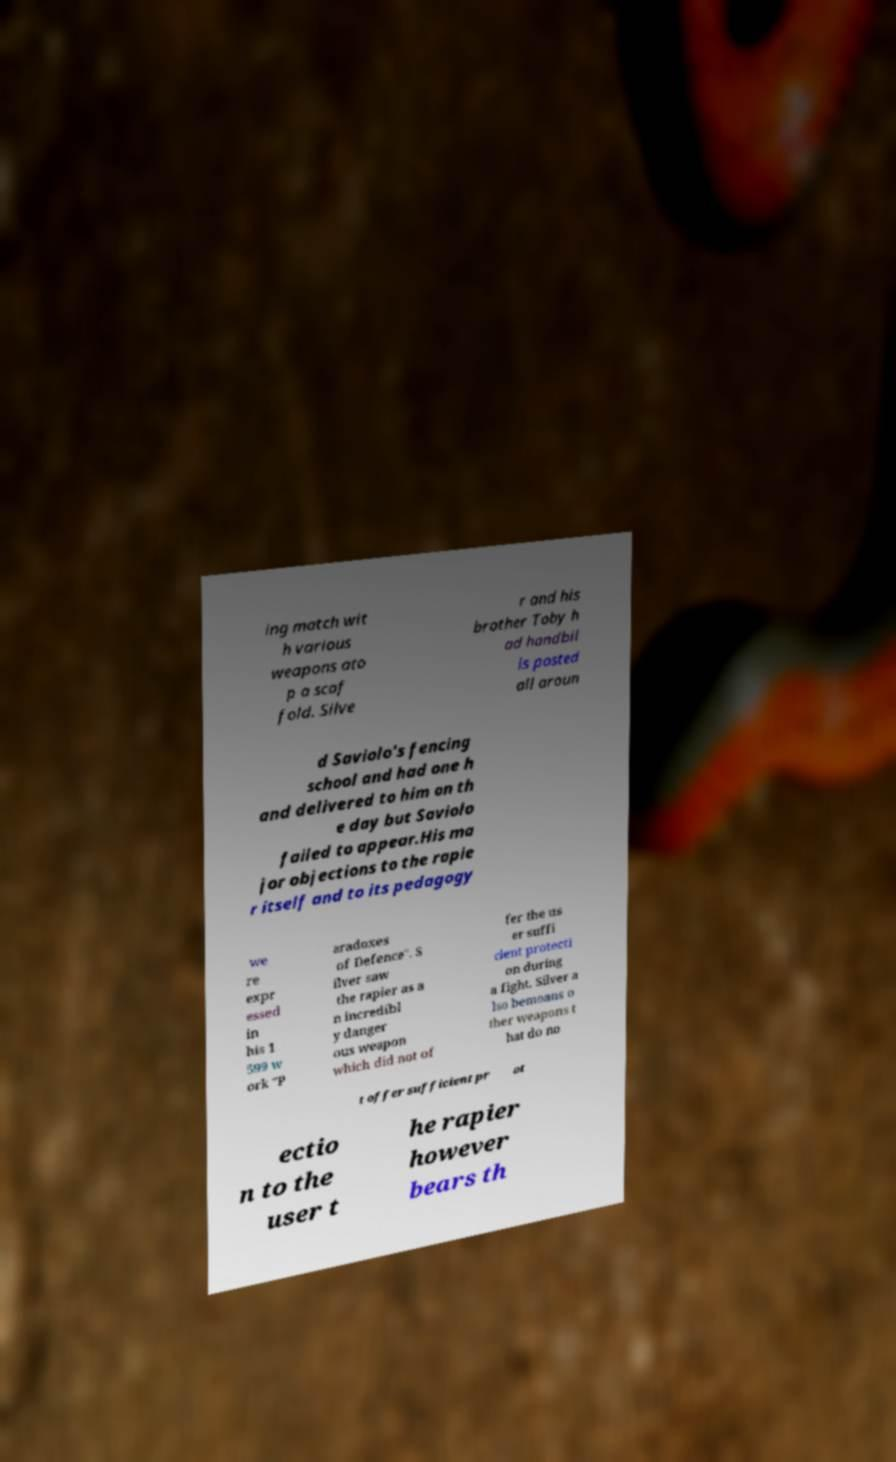I need the written content from this picture converted into text. Can you do that? ing match wit h various weapons ato p a scaf fold. Silve r and his brother Toby h ad handbil ls posted all aroun d Saviolo's fencing school and had one h and delivered to him on th e day but Saviolo failed to appear.His ma jor objections to the rapie r itself and to its pedagogy we re expr essed in his 1 599 w ork "P aradoxes of Defence". S ilver saw the rapier as a n incredibl y danger ous weapon which did not of fer the us er suffi cient protecti on during a fight. Silver a lso bemoans o ther weapons t hat do no t offer sufficient pr ot ectio n to the user t he rapier however bears th 